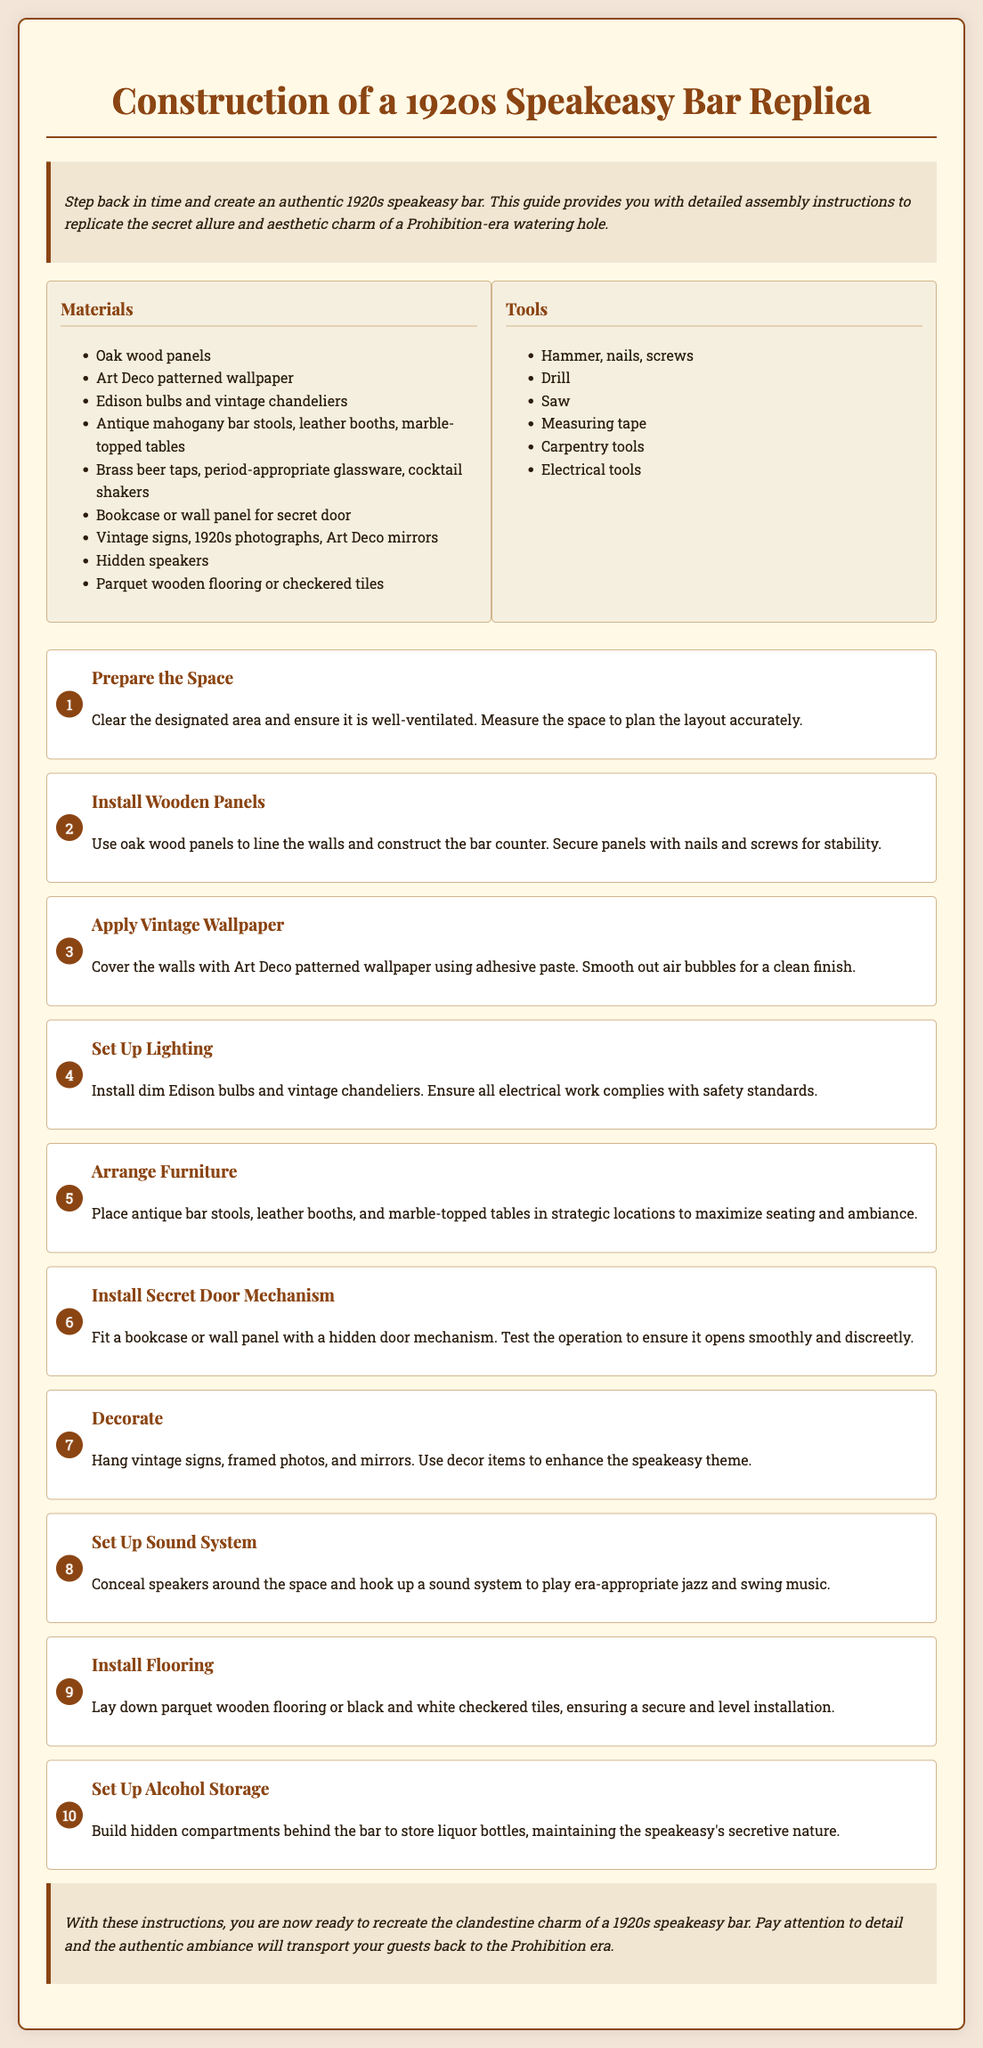What is the title of the guide? The title of the guide is stated at the top of the document, which is "Construction of a 1920s Speakeasy Bar Replica."
Answer: Construction of a 1920s Speakeasy Bar Replica How many types of bulbs are mentioned for lighting? The document specifies the types of bulbs to be used for lighting, which are "Edison bulbs and vintage chandeliers."
Answer: Two What is the first step in the assembly instructions? The first step listed in the assembly instructions is "Prepare the Space."
Answer: Prepare the Space What type of flooring is suggested in the guide? The guide mentions two types of flooring options: "parquet wooden flooring or checkered tiles."
Answer: Parquet wooden flooring or checkered tiles What materials are listed for the furniture? The materials mentioned for the furniture include "antique mahogany bar stools, leather booths, marble-topped tables."
Answer: Antique mahogany bar stools, leather booths, marble-topped tables How should the secret door be installed? According to the assembly guide, the secret door should be installed using a "bookcase or wall panel."
Answer: Bookcase or wall panel What decorative items are suggested to enhance the theme? The document lists "vintage signs, 1920s photographs, Art Deco mirrors."
Answer: Vintage signs, 1920s photographs, Art Deco mirrors What is emphasized about the bar's alcohol storage? The guide emphasizes maintaining a "hidden compartments behind the bar."
Answer: Hidden compartments behind the bar How should the lighting comply with safety standards? The document advises that installation of the lighting should ensure that "all electrical work complies with safety standards."
Answer: Complies with safety standards 